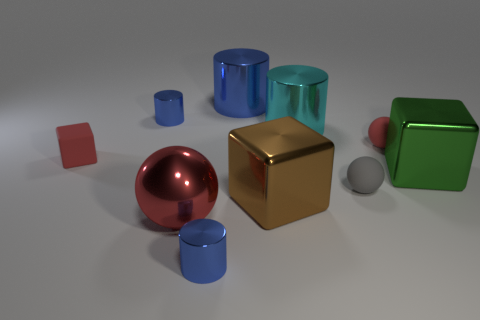Does the tiny cylinder left of the big metallic sphere have the same material as the large sphere?
Ensure brevity in your answer.  Yes. How many spheres are cyan objects or tiny things?
Offer a very short reply. 2. There is a big object to the left of the tiny cylinder that is in front of the red cube on the left side of the red rubber ball; what shape is it?
Provide a succinct answer. Sphere. What number of red things have the same size as the matte cube?
Offer a terse response. 1. There is a tiny cylinder that is behind the green block; is there a red object right of it?
Ensure brevity in your answer.  Yes. How many objects are either blue rubber balls or big things?
Ensure brevity in your answer.  5. What is the color of the metallic cube on the left side of the shiny object right of the matte thing to the right of the gray rubber thing?
Your answer should be very brief. Brown. Is there anything else that is the same color as the small matte block?
Your response must be concise. Yes. Is the size of the matte cube the same as the red shiny object?
Your answer should be very brief. No. How many objects are rubber things that are in front of the green shiny cube or tiny objects on the left side of the tiny gray matte sphere?
Provide a succinct answer. 4. 